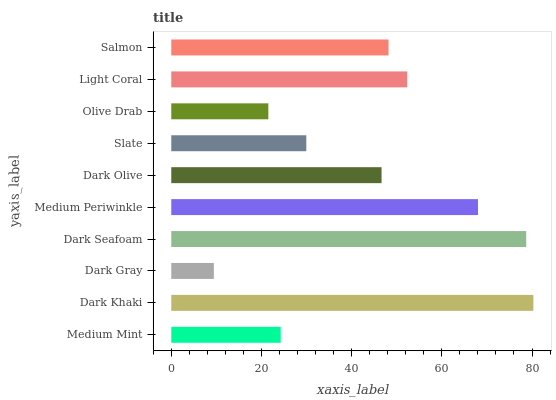Is Dark Gray the minimum?
Answer yes or no. Yes. Is Dark Khaki the maximum?
Answer yes or no. Yes. Is Dark Khaki the minimum?
Answer yes or no. No. Is Dark Gray the maximum?
Answer yes or no. No. Is Dark Khaki greater than Dark Gray?
Answer yes or no. Yes. Is Dark Gray less than Dark Khaki?
Answer yes or no. Yes. Is Dark Gray greater than Dark Khaki?
Answer yes or no. No. Is Dark Khaki less than Dark Gray?
Answer yes or no. No. Is Salmon the high median?
Answer yes or no. Yes. Is Dark Olive the low median?
Answer yes or no. Yes. Is Slate the high median?
Answer yes or no. No. Is Dark Gray the low median?
Answer yes or no. No. 